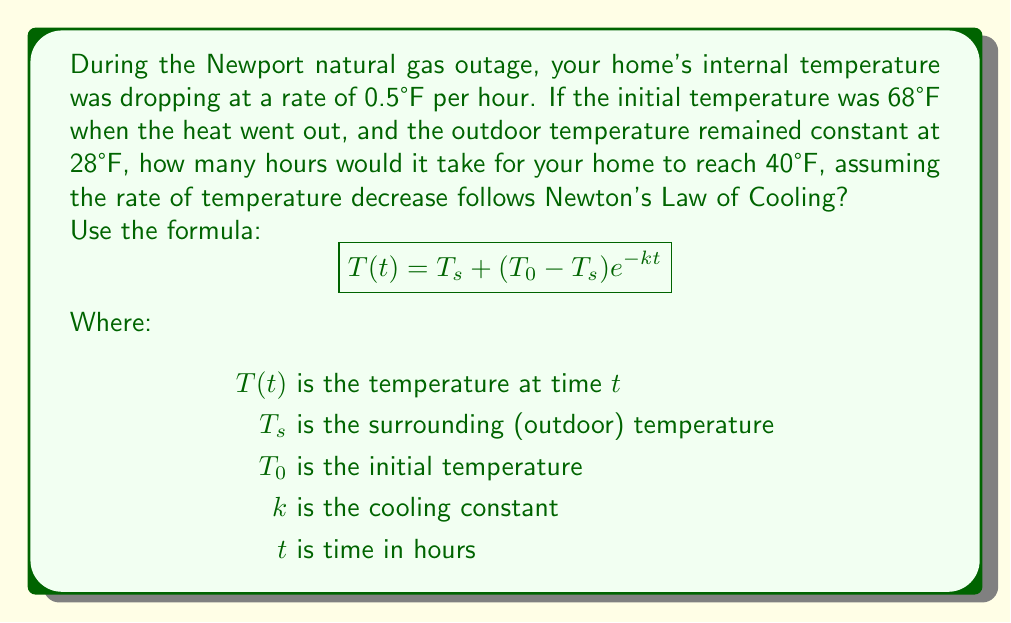Solve this math problem. 1. First, we need to find the cooling constant $k$ using the given rate of temperature decrease:

   At $t=1$ hour, the temperature drops by 0.5°F, so:
   $$68 - 0.5 = 28 + (68 - 28)e^{-k(1)}$$
   $$67.5 = 28 + 40e^{-k}$$
   $$39.5 = 40e^{-k}$$
   $$\ln(0.9875) = -k$$
   $$k \approx 0.0126$$

2. Now we can use Newton's Law of Cooling formula to find $t$ when $T(t) = 40°F$:
   $$40 = 28 + (68 - 28)e^{-0.0126t}$$

3. Solve for $t$:
   $$12 = 40e^{-0.0126t}$$
   $$0.3 = e^{-0.0126t}$$
   $$\ln(0.3) = -0.0126t$$
   $$t = \frac{\ln(0.3)}{-0.0126} \approx 95.95$$

4. Round to the nearest hour:
   $t \approx 96$ hours
Answer: 96 hours 